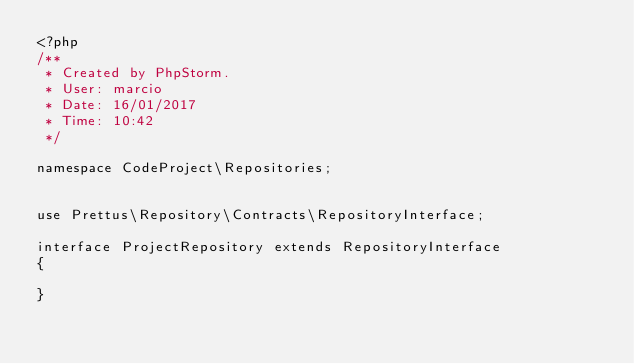Convert code to text. <code><loc_0><loc_0><loc_500><loc_500><_PHP_><?php
/**
 * Created by PhpStorm.
 * User: marcio
 * Date: 16/01/2017
 * Time: 10:42
 */

namespace CodeProject\Repositories;


use Prettus\Repository\Contracts\RepositoryInterface;

interface ProjectRepository extends RepositoryInterface
{

}</code> 